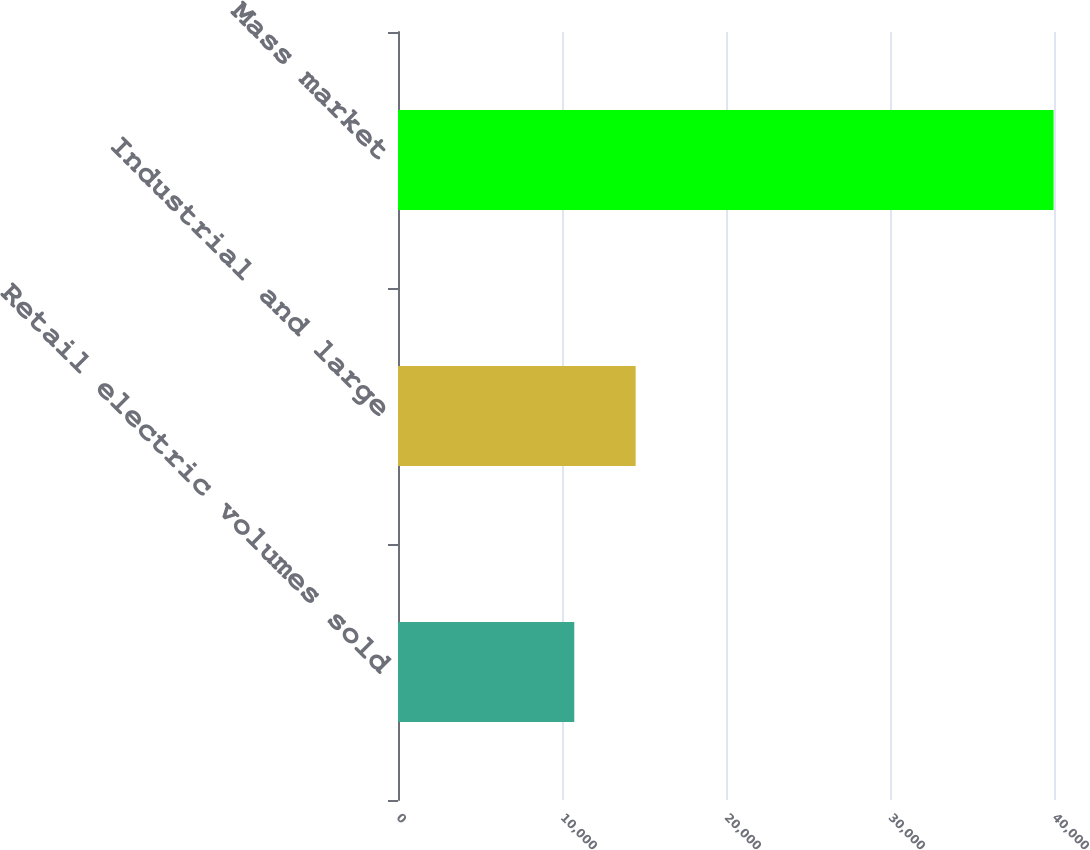Convert chart. <chart><loc_0><loc_0><loc_500><loc_500><bar_chart><fcel>Retail electric volumes sold<fcel>Industrial and large<fcel>Mass market<nl><fcel>10749<fcel>14491<fcel>39976<nl></chart> 